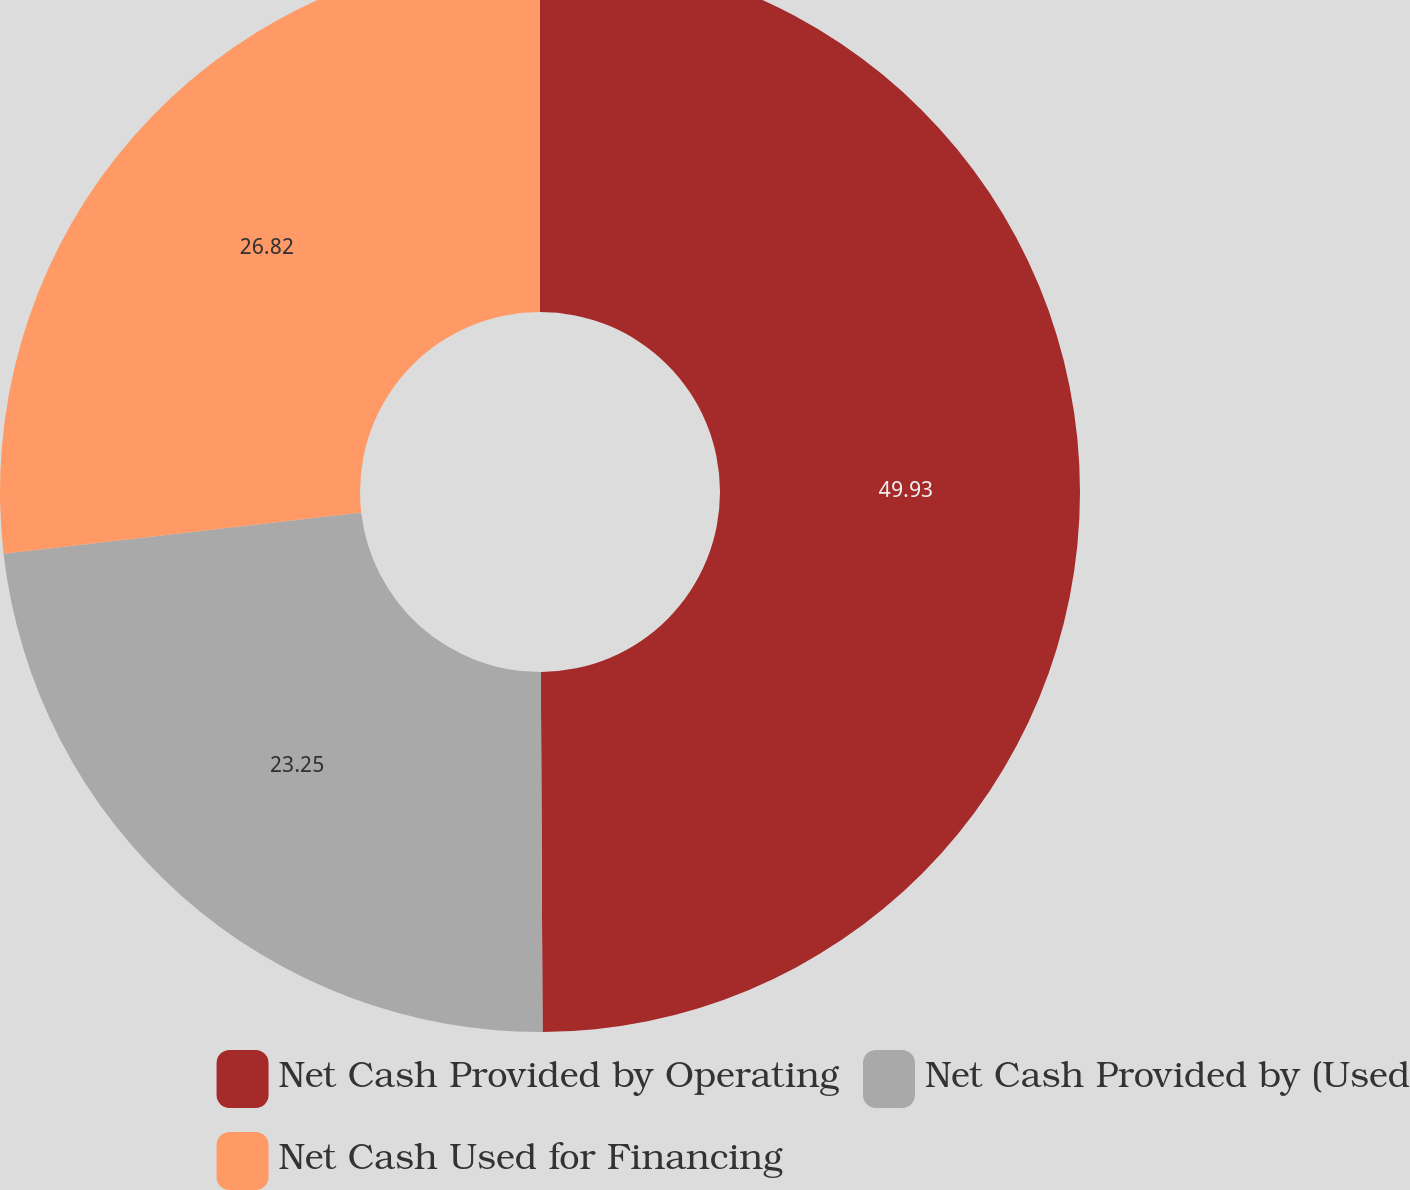Convert chart to OTSL. <chart><loc_0><loc_0><loc_500><loc_500><pie_chart><fcel>Net Cash Provided by Operating<fcel>Net Cash Provided by (Used<fcel>Net Cash Used for Financing<nl><fcel>49.92%<fcel>23.25%<fcel>26.82%<nl></chart> 